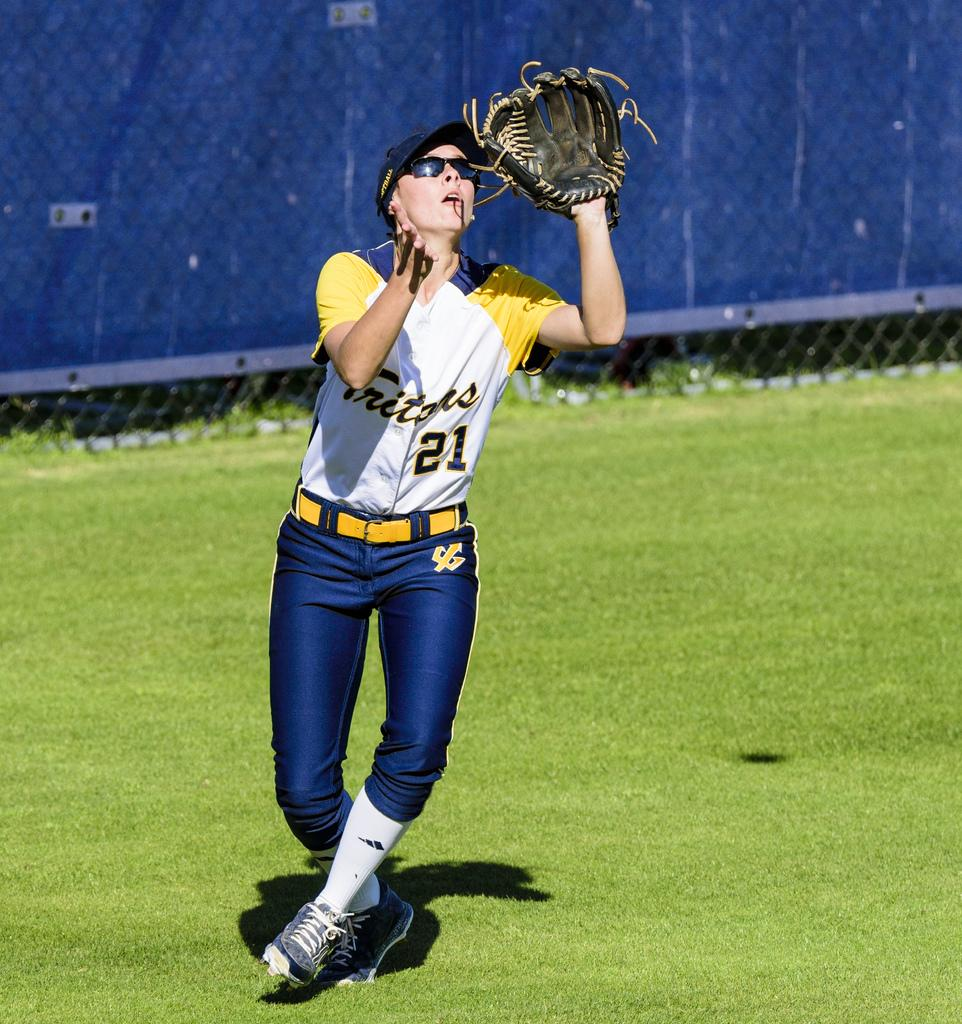Who or what is present in the image? There is a person in the image. What accessories is the person wearing? The person is wearing gloves, spectacles, and a hat. What can be seen in the background of the image? There is a fencing visible in the image. What order is the person in the image trying to maintain? There is no indication in the image that the person is part of an order or trying to maintain one. 